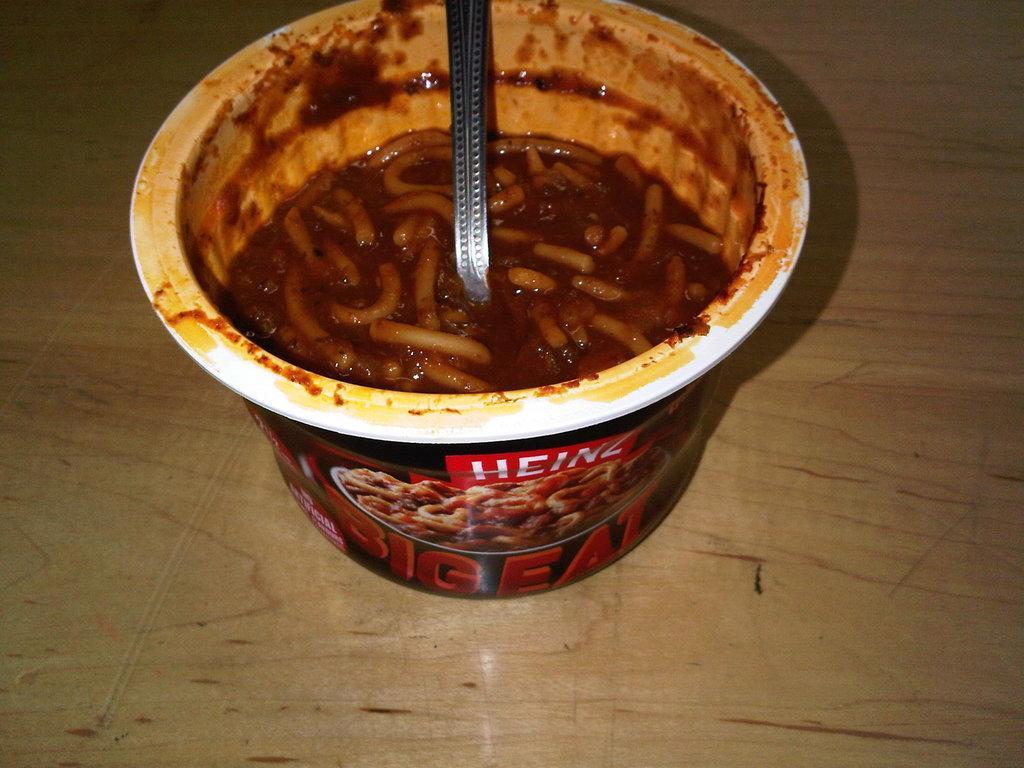Could you give a brief overview of what you see in this image? In this image there is a spoon in the cup noodles on the table. 